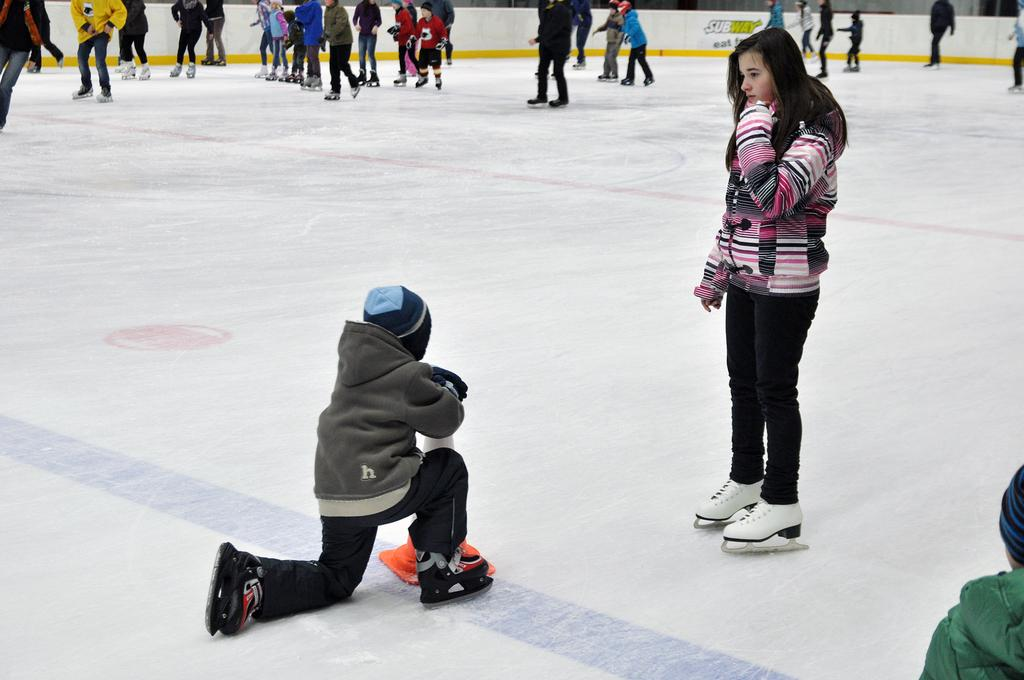What activity are some people in the image engaged in? Some people in the image are skating on the ice. What type of shoes are the skaters using? The skaters are using shoes to skate. What object can be seen in the middle of the image? There is a road divider cone in the middle of the image. What riddle is being solved by the people in the image? There is no riddle being solved in the image; the people are skating on the ice. What type of street is visible in the image? The image does not show a street; it shows people skating on ice. 